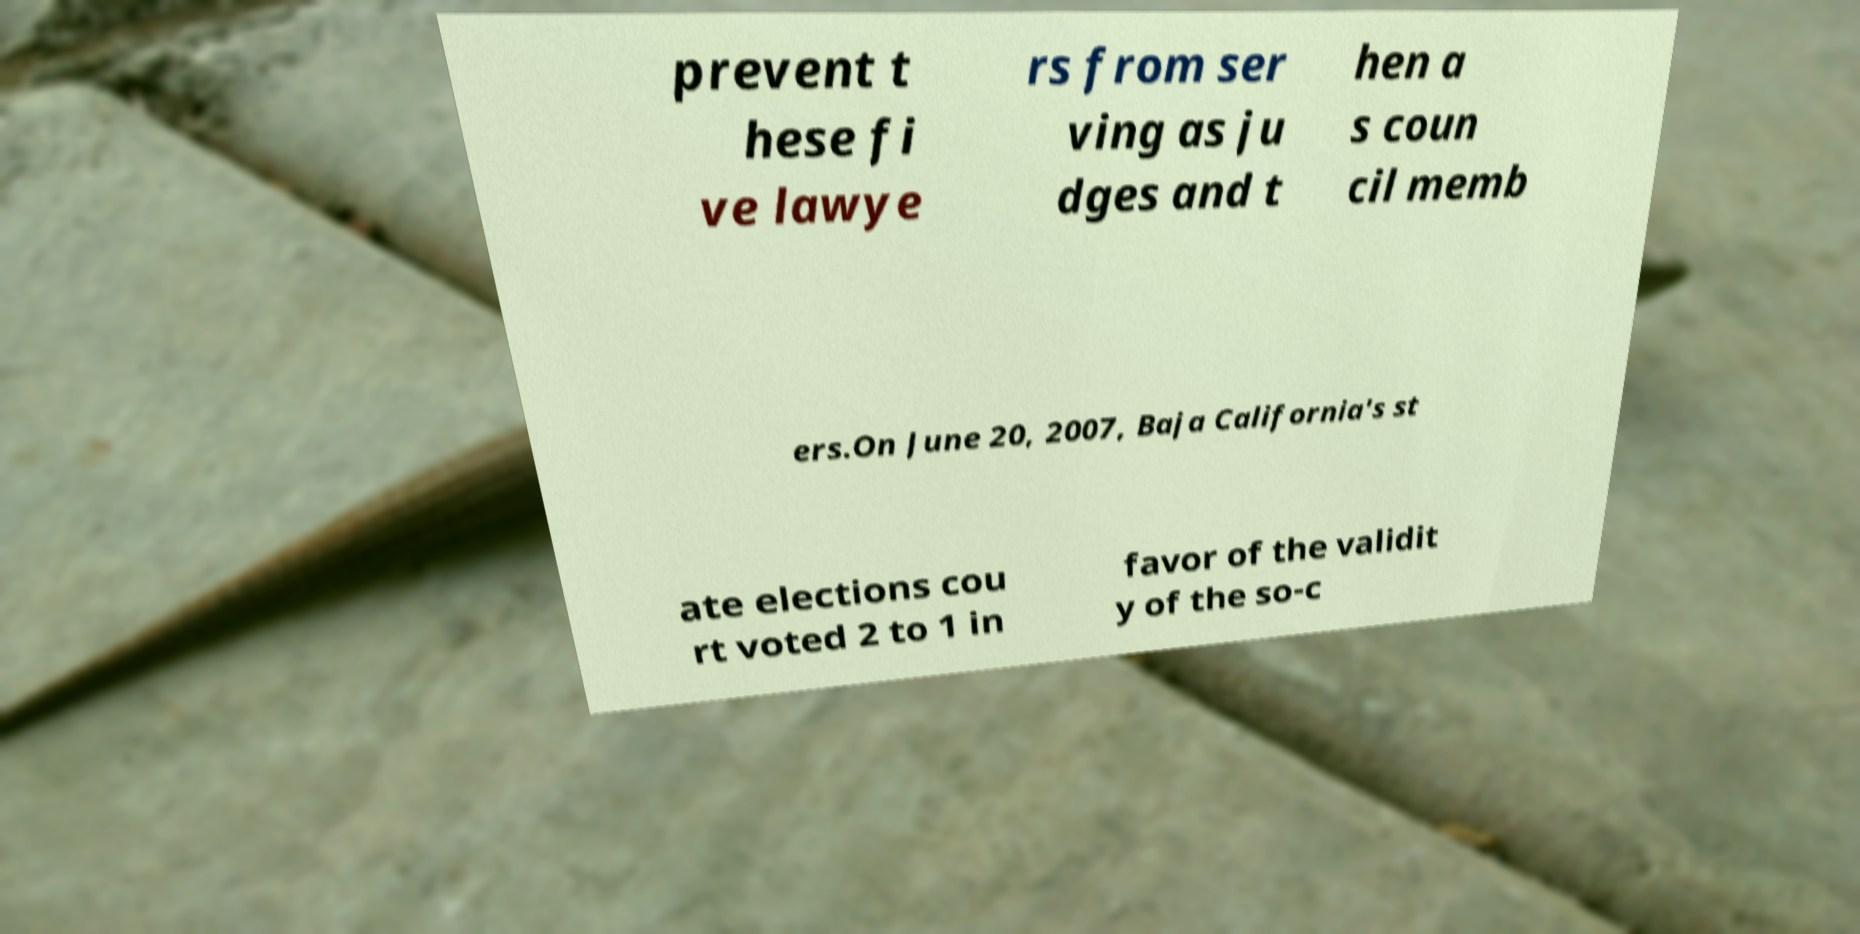Can you read and provide the text displayed in the image?This photo seems to have some interesting text. Can you extract and type it out for me? prevent t hese fi ve lawye rs from ser ving as ju dges and t hen a s coun cil memb ers.On June 20, 2007, Baja California's st ate elections cou rt voted 2 to 1 in favor of the validit y of the so-c 